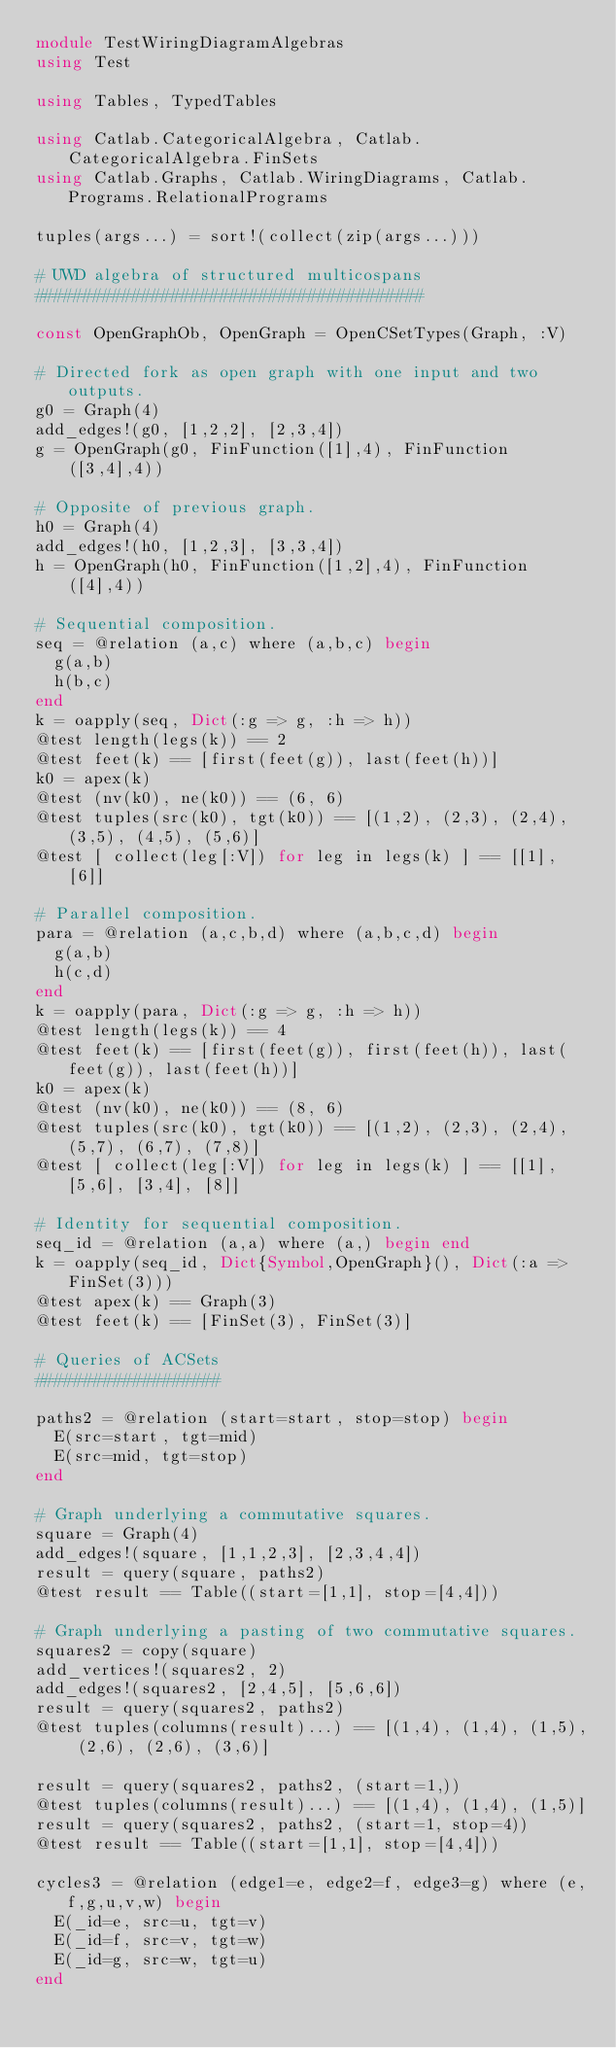Convert code to text. <code><loc_0><loc_0><loc_500><loc_500><_Julia_>module TestWiringDiagramAlgebras
using Test

using Tables, TypedTables

using Catlab.CategoricalAlgebra, Catlab.CategoricalAlgebra.FinSets
using Catlab.Graphs, Catlab.WiringDiagrams, Catlab.Programs.RelationalPrograms

tuples(args...) = sort!(collect(zip(args...)))

# UWD algebra of structured multicospans
########################################

const OpenGraphOb, OpenGraph = OpenCSetTypes(Graph, :V)

# Directed fork as open graph with one input and two outputs.
g0 = Graph(4)
add_edges!(g0, [1,2,2], [2,3,4])
g = OpenGraph(g0, FinFunction([1],4), FinFunction([3,4],4))

# Opposite of previous graph.
h0 = Graph(4)
add_edges!(h0, [1,2,3], [3,3,4])
h = OpenGraph(h0, FinFunction([1,2],4), FinFunction([4],4))

# Sequential composition.
seq = @relation (a,c) where (a,b,c) begin
  g(a,b)
  h(b,c)
end
k = oapply(seq, Dict(:g => g, :h => h))
@test length(legs(k)) == 2
@test feet(k) == [first(feet(g)), last(feet(h))]
k0 = apex(k)
@test (nv(k0), ne(k0)) == (6, 6)
@test tuples(src(k0), tgt(k0)) == [(1,2), (2,3), (2,4), (3,5), (4,5), (5,6)]
@test [ collect(leg[:V]) for leg in legs(k) ] == [[1], [6]]

# Parallel composition.
para = @relation (a,c,b,d) where (a,b,c,d) begin
  g(a,b)
  h(c,d)
end
k = oapply(para, Dict(:g => g, :h => h))
@test length(legs(k)) == 4
@test feet(k) == [first(feet(g)), first(feet(h)), last(feet(g)), last(feet(h))]
k0 = apex(k)
@test (nv(k0), ne(k0)) == (8, 6)
@test tuples(src(k0), tgt(k0)) == [(1,2), (2,3), (2,4), (5,7), (6,7), (7,8)]
@test [ collect(leg[:V]) for leg in legs(k) ] == [[1], [5,6], [3,4], [8]]

# Identity for sequential composition.
seq_id = @relation (a,a) where (a,) begin end
k = oapply(seq_id, Dict{Symbol,OpenGraph}(), Dict(:a => FinSet(3)))
@test apex(k) == Graph(3)
@test feet(k) == [FinSet(3), FinSet(3)]

# Queries of ACSets
###################

paths2 = @relation (start=start, stop=stop) begin
  E(src=start, tgt=mid)
  E(src=mid, tgt=stop)
end

# Graph underlying a commutative squares.
square = Graph(4)
add_edges!(square, [1,1,2,3], [2,3,4,4])
result = query(square, paths2)
@test result == Table((start=[1,1], stop=[4,4]))

# Graph underlying a pasting of two commutative squares.
squares2 = copy(square)
add_vertices!(squares2, 2)
add_edges!(squares2, [2,4,5], [5,6,6])
result = query(squares2, paths2)
@test tuples(columns(result)...) == [(1,4), (1,4), (1,5), (2,6), (2,6), (3,6)]

result = query(squares2, paths2, (start=1,))
@test tuples(columns(result)...) == [(1,4), (1,4), (1,5)]
result = query(squares2, paths2, (start=1, stop=4))
@test result == Table((start=[1,1], stop=[4,4]))

cycles3 = @relation (edge1=e, edge2=f, edge3=g) where (e,f,g,u,v,w) begin
  E(_id=e, src=u, tgt=v)
  E(_id=f, src=v, tgt=w)
  E(_id=g, src=w, tgt=u)
end
</code> 